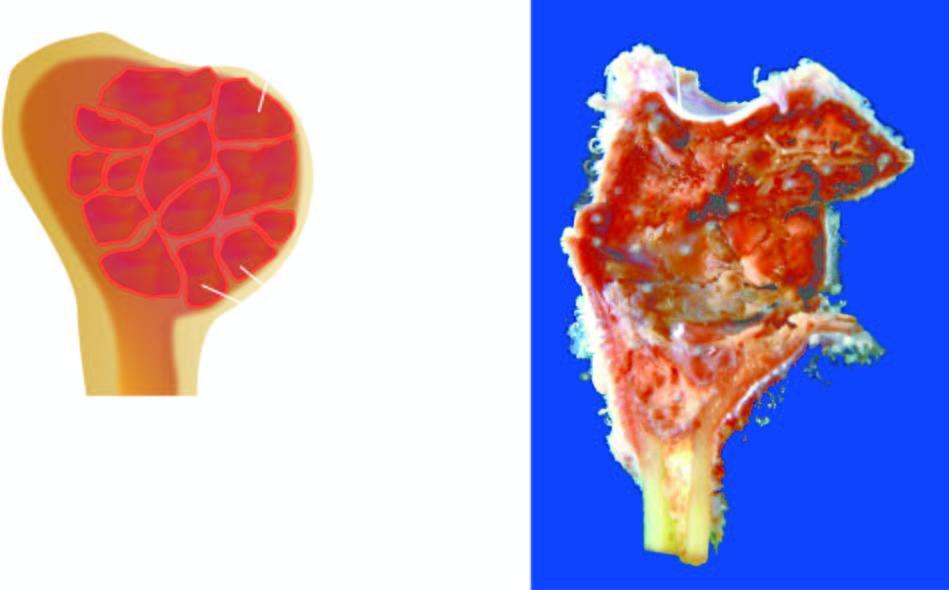s the end of the long bone expanded due to a cyst?
Answer the question using a single word or phrase. Yes 